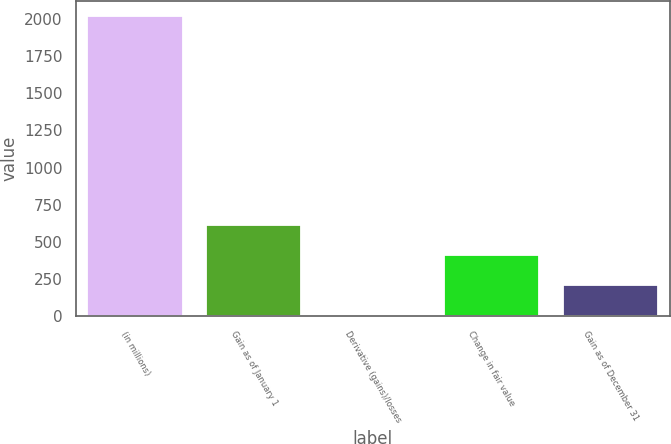Convert chart. <chart><loc_0><loc_0><loc_500><loc_500><bar_chart><fcel>(in millions)<fcel>Gain as of January 1<fcel>Derivative (gains)/losses<fcel>Change in fair value<fcel>Gain as of December 31<nl><fcel>2017<fcel>612.8<fcel>11<fcel>412.2<fcel>211.6<nl></chart> 